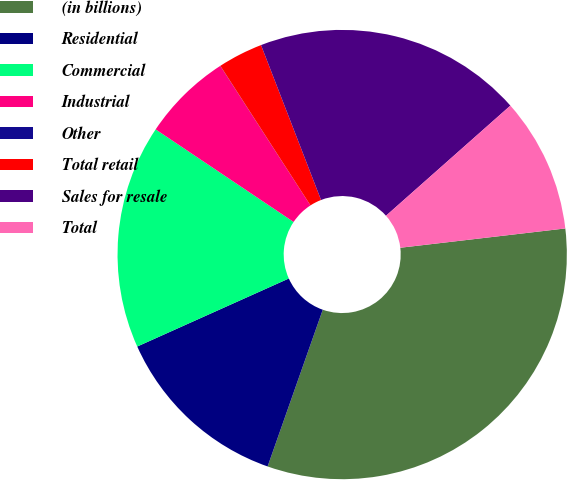<chart> <loc_0><loc_0><loc_500><loc_500><pie_chart><fcel>(in billions)<fcel>Residential<fcel>Commercial<fcel>Industrial<fcel>Other<fcel>Total retail<fcel>Sales for resale<fcel>Total<nl><fcel>32.24%<fcel>12.9%<fcel>16.12%<fcel>6.46%<fcel>0.01%<fcel>3.24%<fcel>19.35%<fcel>9.68%<nl></chart> 